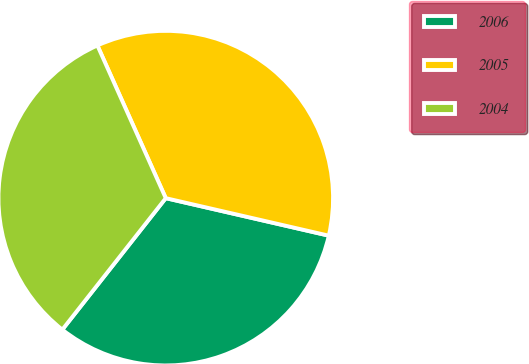Convert chart. <chart><loc_0><loc_0><loc_500><loc_500><pie_chart><fcel>2006<fcel>2005<fcel>2004<nl><fcel>32.01%<fcel>35.3%<fcel>32.69%<nl></chart> 